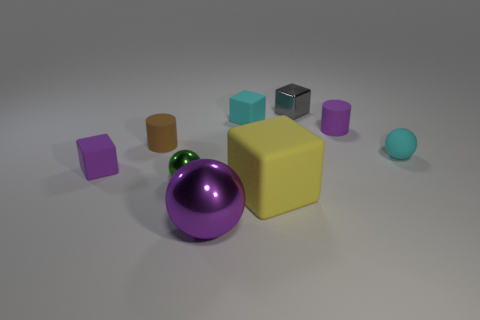How many shiny things are either gray blocks or purple spheres?
Your answer should be compact. 2. Do the large sphere and the yellow thing have the same material?
Offer a terse response. No. There is a purple object in front of the purple rubber block; what shape is it?
Offer a terse response. Sphere. Is there a brown matte object that is right of the tiny cyan object that is behind the tiny brown cylinder?
Your answer should be compact. No. Are there any yellow rubber blocks that have the same size as the brown cylinder?
Offer a very short reply. No. There is a small thing on the left side of the tiny brown matte cylinder; is its color the same as the small metal cube?
Make the answer very short. No. What is the size of the brown cylinder?
Ensure brevity in your answer.  Small. There is a purple rubber thing that is in front of the cyan matte thing in front of the tiny brown object; how big is it?
Make the answer very short. Small. What number of tiny rubber things have the same color as the matte ball?
Make the answer very short. 1. How many metal objects are there?
Make the answer very short. 3. 